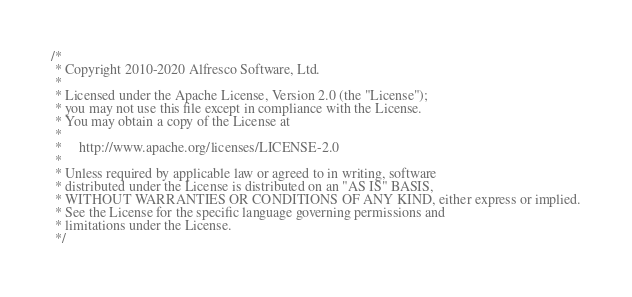<code> <loc_0><loc_0><loc_500><loc_500><_Java_>/*
 * Copyright 2010-2020 Alfresco Software, Ltd.
 *
 * Licensed under the Apache License, Version 2.0 (the "License");
 * you may not use this file except in compliance with the License.
 * You may obtain a copy of the License at
 *
 *     http://www.apache.org/licenses/LICENSE-2.0
 *
 * Unless required by applicable law or agreed to in writing, software
 * distributed under the License is distributed on an "AS IS" BASIS,
 * WITHOUT WARRANTIES OR CONDITIONS OF ANY KIND, either express or implied.
 * See the License for the specific language governing permissions and
 * limitations under the License.
 */</code> 